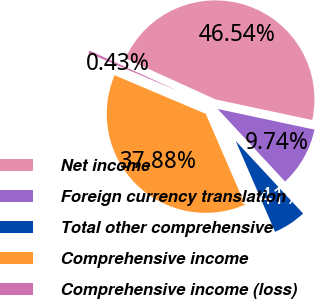<chart> <loc_0><loc_0><loc_500><loc_500><pie_chart><fcel>Net income<fcel>Foreign currency translation<fcel>Total other comprehensive<fcel>Comprehensive income<fcel>Comprehensive income (loss)<nl><fcel>46.54%<fcel>9.74%<fcel>5.41%<fcel>37.88%<fcel>0.43%<nl></chart> 